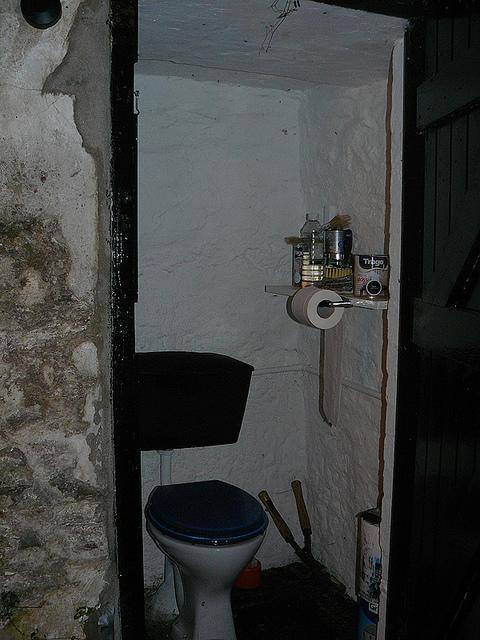How many toilets do you see?
Give a very brief answer. 1. How many park benches have been flooded?
Give a very brief answer. 0. 